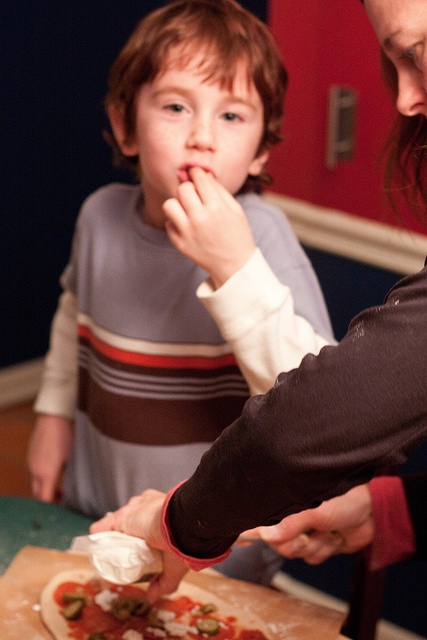Describe the objects in this image and their specific colors. I can see people in black, maroon, brown, and lightpink tones, people in black, maroon, brown, and salmon tones, dining table in black, tan, salmon, maroon, and brown tones, pizza in black, maroon, brown, and tan tones, and chair in black, gray, tan, and brown tones in this image. 